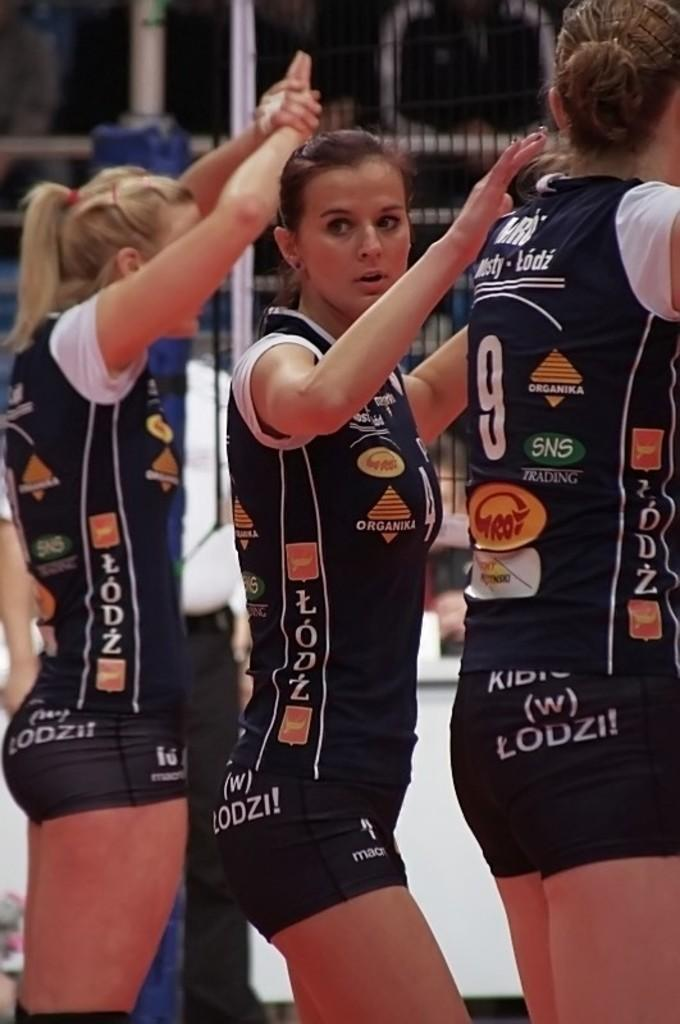<image>
Relay a brief, clear account of the picture shown. Three women wearing a uniform with various sponsors like SNS trading. 